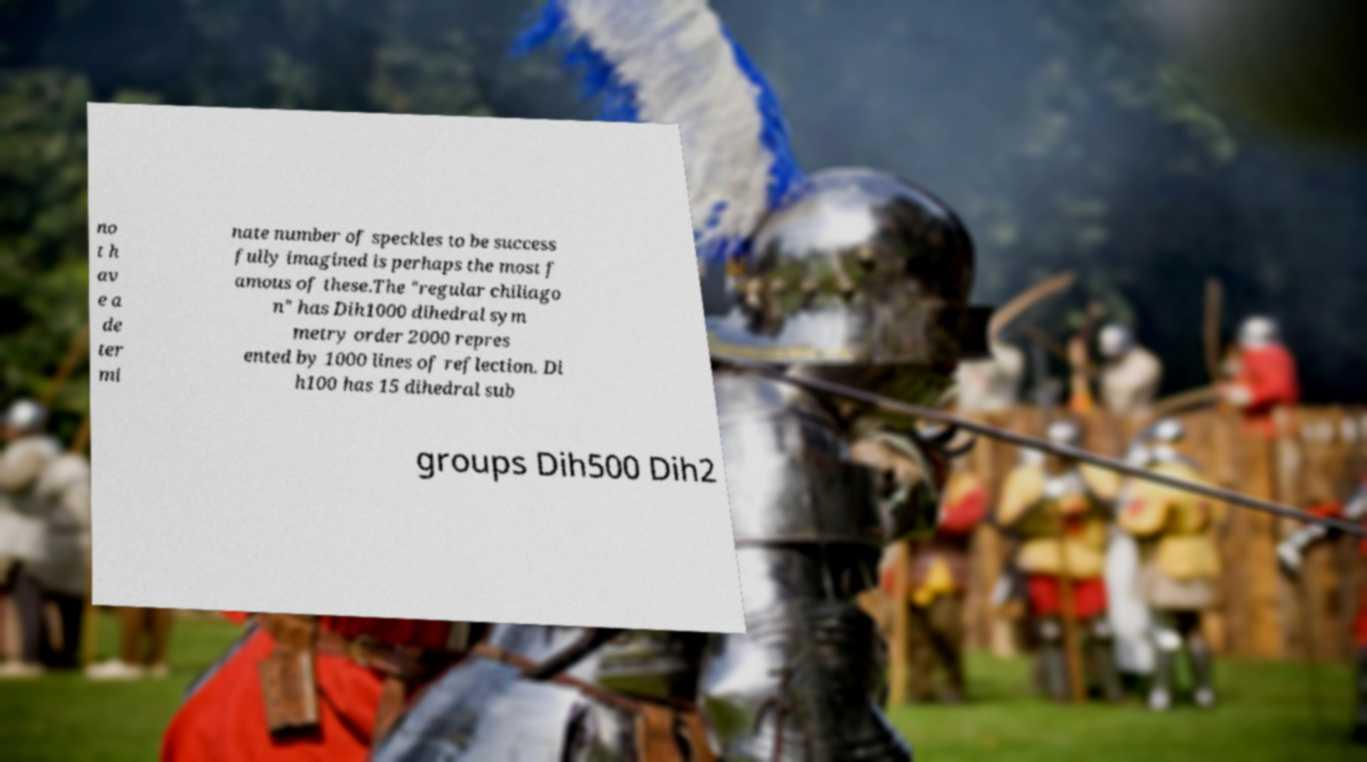Could you extract and type out the text from this image? no t h av e a de ter mi nate number of speckles to be success fully imagined is perhaps the most f amous of these.The "regular chiliago n" has Dih1000 dihedral sym metry order 2000 repres ented by 1000 lines of reflection. Di h100 has 15 dihedral sub groups Dih500 Dih2 